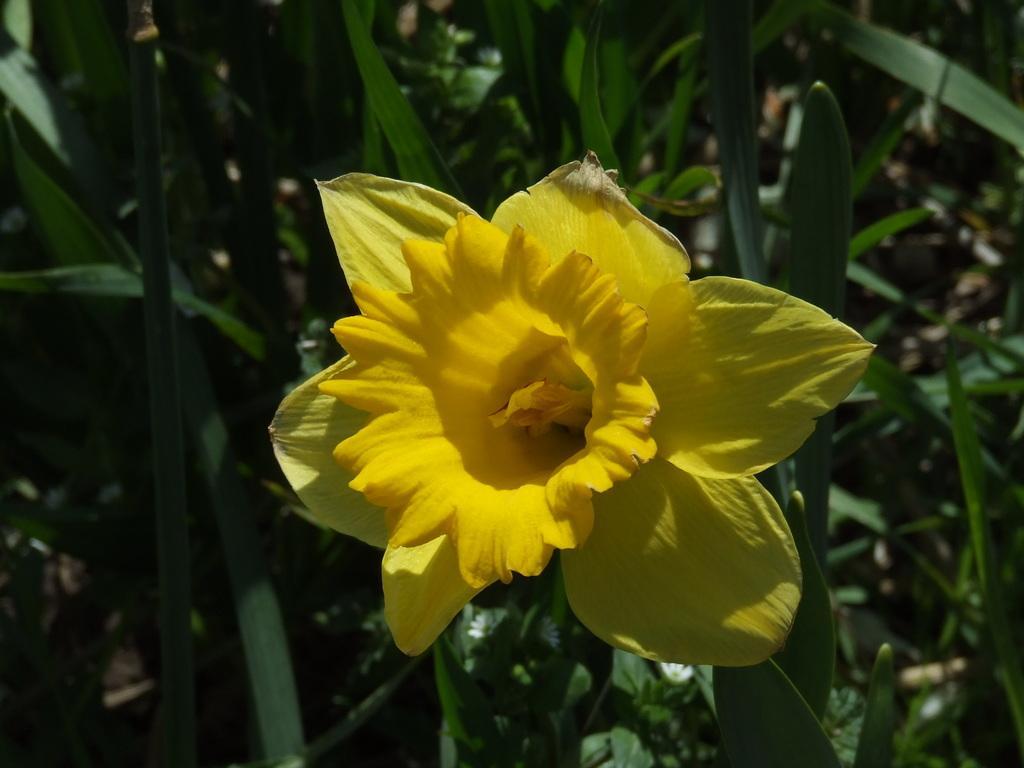Describe this image in one or two sentences. In the middle of the picture, we see the flower in yellow color. In the background, we see the trees or plants. This picture is blurred in the background. 